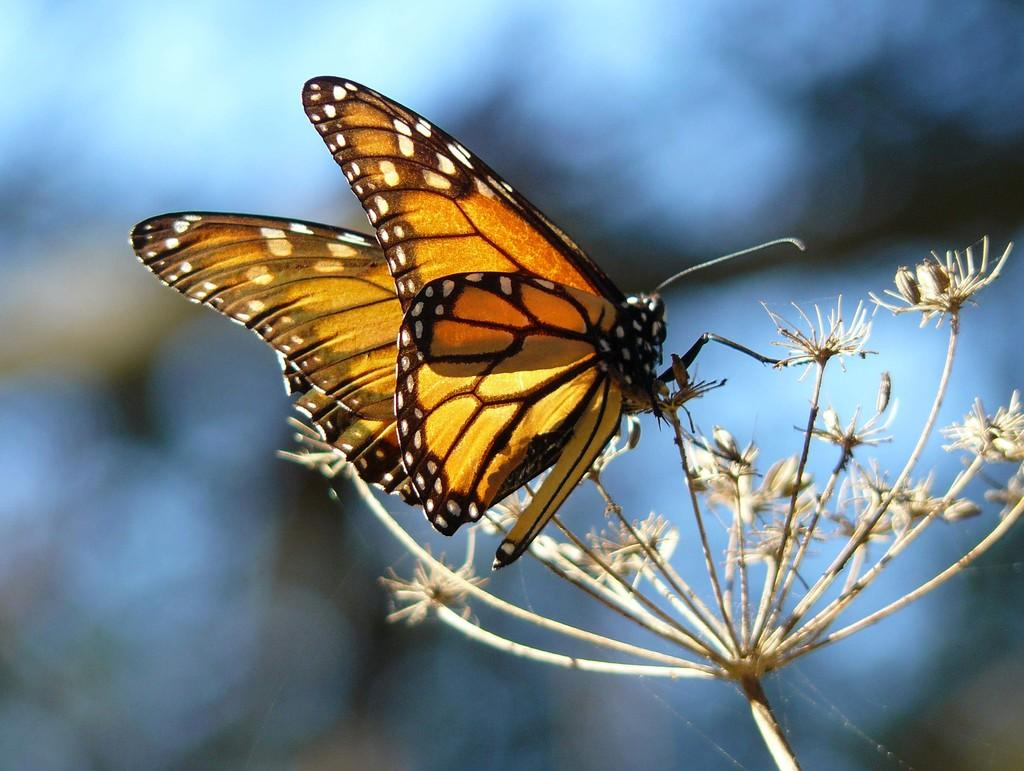Where was the image likely taken? The image was likely taken outside. What is the main subject in the foreground of the image? There is a moth in the foreground of the image. What is the moth resting on in the image? The moth appears to be on a flower-like object. Can you describe the background of the image? The background of the image is blurry. What time does the watch in the image show? There is no watch present in the image. What is the texture of the chin in the image? There is no chin present in the image. 